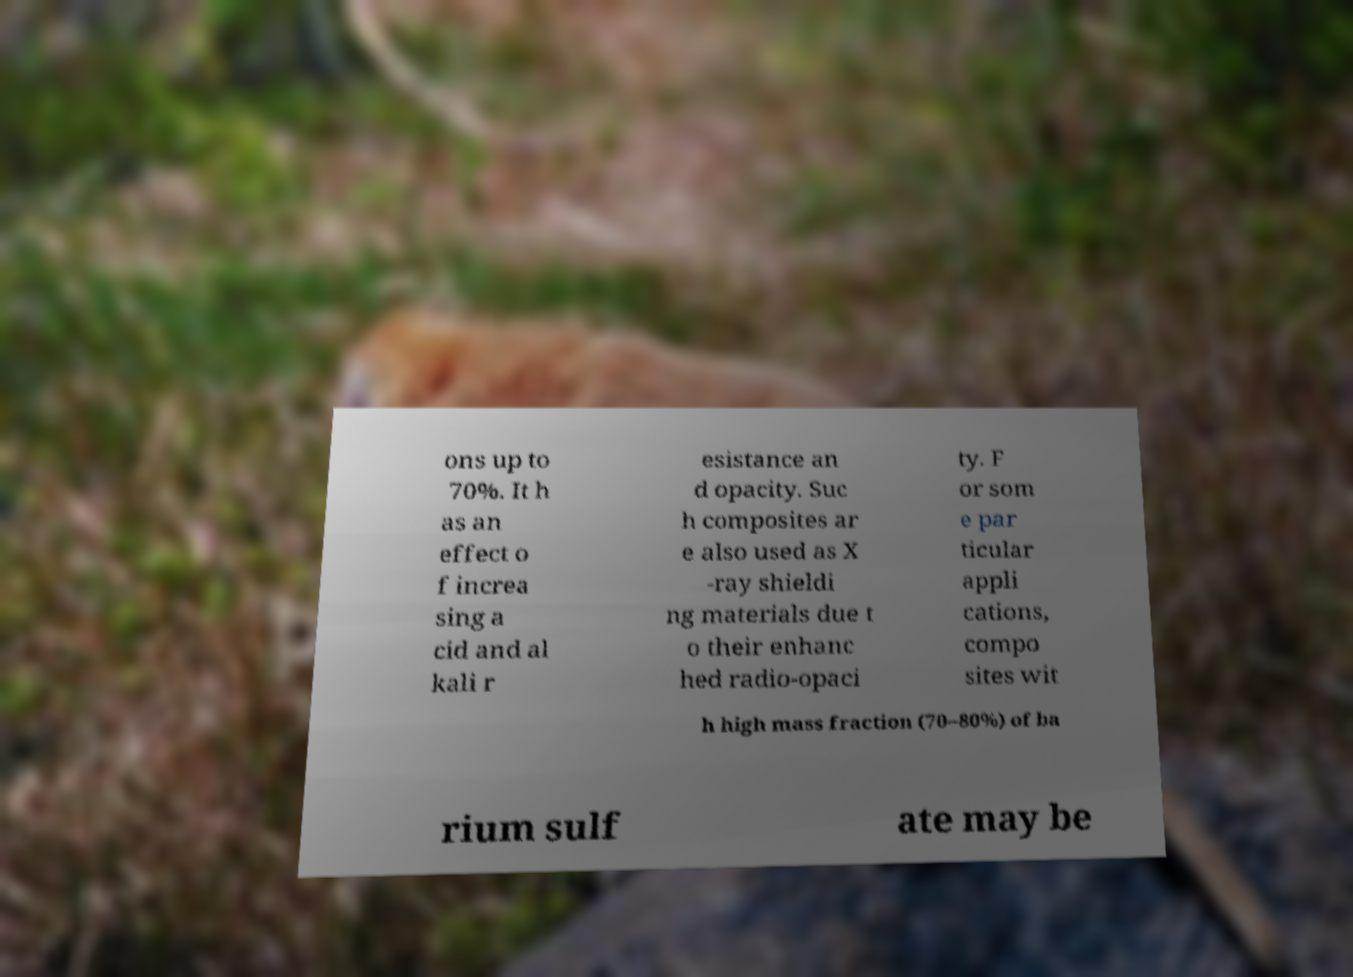I need the written content from this picture converted into text. Can you do that? ons up to 70%. It h as an effect o f increa sing a cid and al kali r esistance an d opacity. Suc h composites ar e also used as X -ray shieldi ng materials due t o their enhanc hed radio-opaci ty. F or som e par ticular appli cations, compo sites wit h high mass fraction (70–80%) of ba rium sulf ate may be 